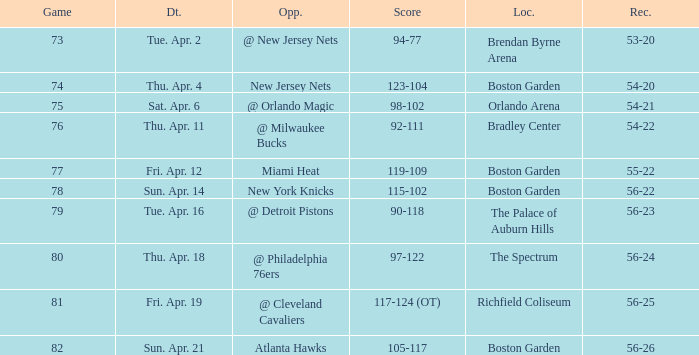Which Opponent has a Score of 92-111? @ Milwaukee Bucks. 